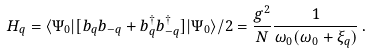<formula> <loc_0><loc_0><loc_500><loc_500>H _ { q } = \langle \Psi _ { 0 } | [ b _ { q } b _ { - q } + b _ { q } ^ { \dagger } b _ { - q } ^ { \dagger } ] | \Psi _ { 0 } \rangle / 2 = \frac { g ^ { 2 } } { N } \frac { 1 } { \omega _ { 0 } ( \omega _ { 0 } + \xi _ { q } ) } \, .</formula> 